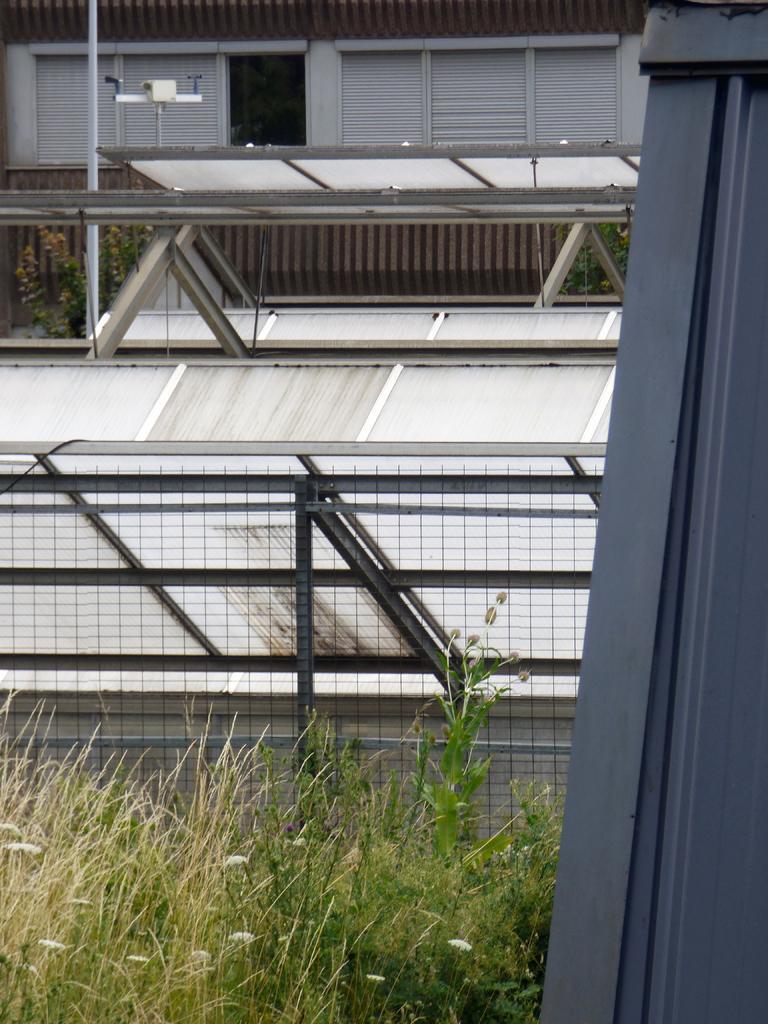Please provide a concise description of this image. In this image in the front there are plants and there is an object. In the background there is a fence and there are plants and there seems to be parts of the buildings. 